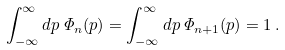<formula> <loc_0><loc_0><loc_500><loc_500>\int _ { - \infty } ^ { \infty } { d } p \, { \mathit \Phi } _ { n } ( p ) = \int _ { - \infty } ^ { \infty } { d } p \, { \mathit \Phi } _ { n + 1 } ( p ) = 1 \, .</formula> 